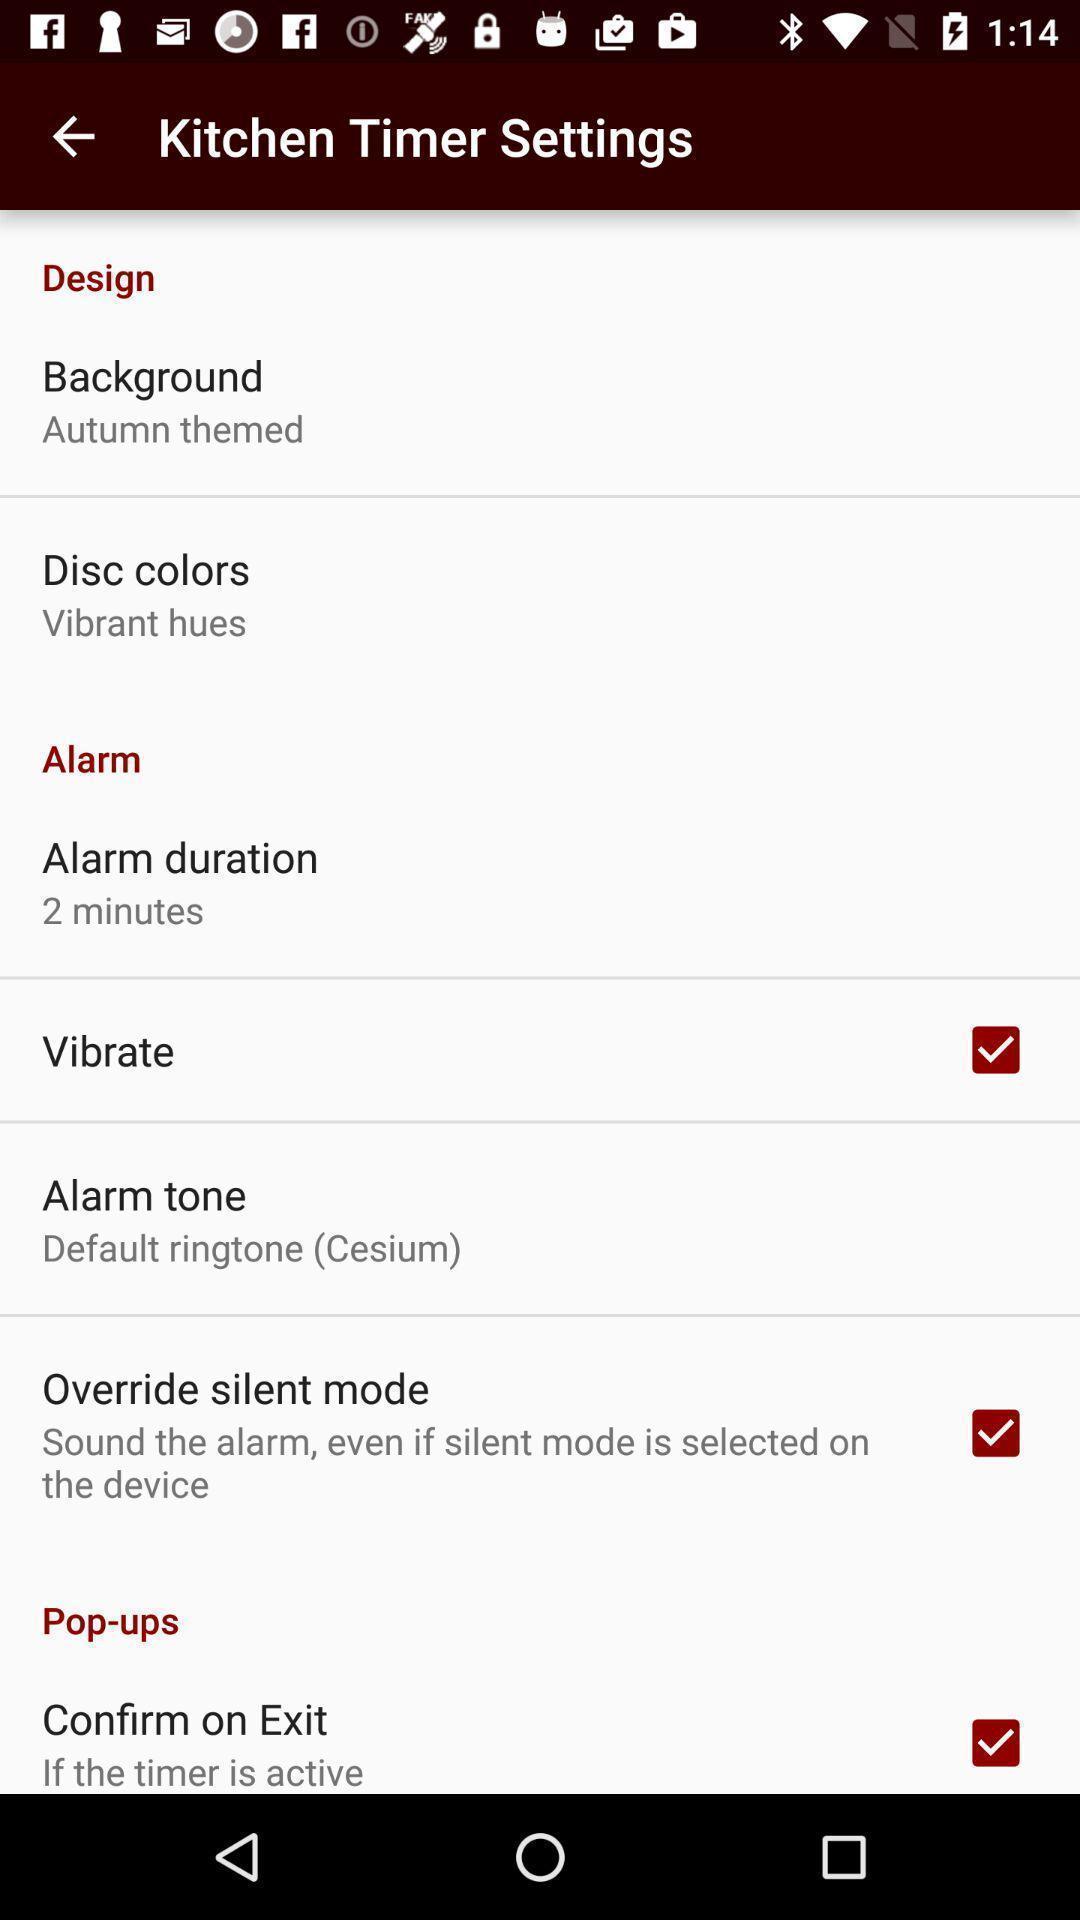Summarize the information in this screenshot. Timer settings for a kitchen. 